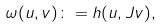<formula> <loc_0><loc_0><loc_500><loc_500>\omega ( u , v ) \colon = h ( u , J v ) ,</formula> 